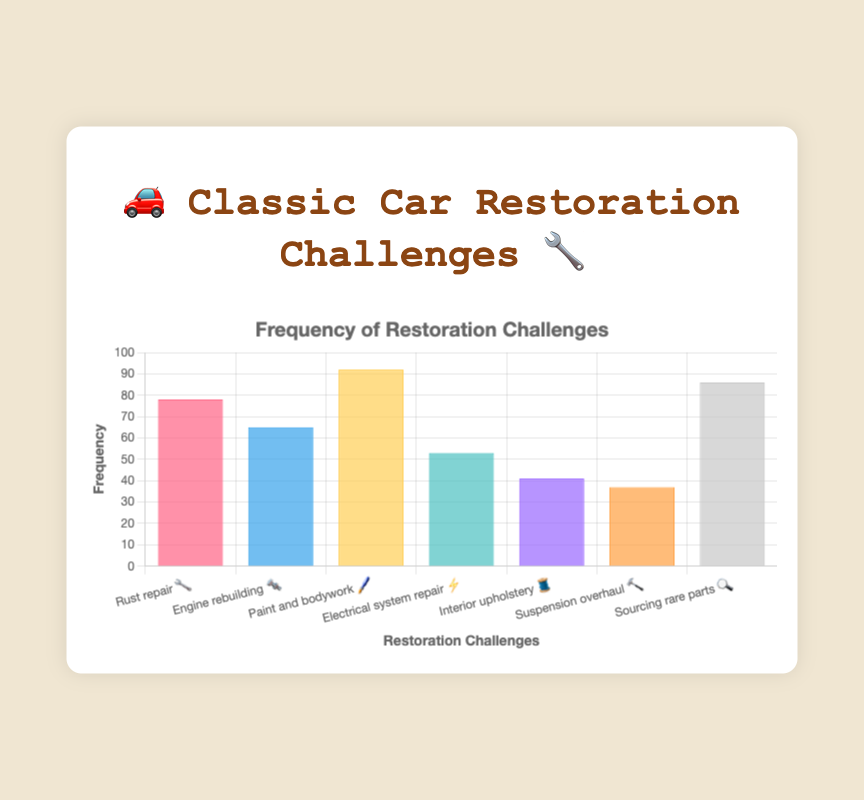what's the highest frequency challenge? The tallest bar in the chart represents the "Paint and bodywork 🖌️" with a frequency of 92.
Answer: Paint and bodywork 🖌️ what's the lowest frequency challenge? The shortest bar in the chart corresponds to the "Suspension overhaul 🔨" with a frequency of 37.
Answer: Suspension overhaul 🔨 which challenge has a frequency of 86? The bar representing "Sourcing rare parts 🔍" has a frequency of 86, as shown by its height.
Answer: Sourcing rare parts 🔍 what is the combined frequency of "Rust repair 🔧" and "Engine rebuilding 🔩"? The sum of the frequencies of "Rust repair 🔧" (78) and "Engine rebuilding 🔩" (65) is 78 + 65 = 143.
Answer: 143 how many challenges have a frequency greater than 50? The challenges with frequencies higher than 50 are "Rust repair 🔧" (78), "Engine rebuilding 🔩" (65), "Paint and bodywork 🖌️" (92), "Electrical system repair ⚡" (53), and "Sourcing rare parts 🔍" (86), totaling 5 challenges.
Answer: 5 which challenge has the second-highest frequency? The second tallest bar represents "Sourcing rare parts 🔍", which has a frequency of 86, placing it second after "Paint and bodywork 🖌️".
Answer: Sourcing rare parts 🔍 is "Interior upholstery 🧵" more or less frequent than "Electrical system repair ⚡"? The "Interior upholstery 🧵" bar has a frequency of 41, while the "Electrical system repair ⚡" bar has a frequency of 53, so "Interior upholstery 🧵" is less frequent than "Electrical system repair ⚡".
Answer: Less frequent what's the total frequency for all challenges combined? Adding the frequencies of all challenges: 78 (Rust repair) + 65 (Engine rebuilding) + 92 (Paint and bodywork) + 53 (Electrical system repair) + 41 (Interior upholstery) + 37 (Suspension overhaul) + 86 (Sourcing rare parts) gives a total of 452.
Answer: 452 which challenges have frequencies between 50 and 80 inclusive? The challenges with frequencies in this range are "Rust repair 🔧" (78), "Engine rebuilding 🔩" (65), and "Electrical system repair ⚡" (53).
Answer: Rust repair 🔧, Engine rebuilding 🔩, Electrical system repair ⚡ what's the average frequency of all the challenges? To find the average, sum all frequencies (452) and divide by the number of challenges (7). So, 452/7 = 64.57.
Answer: 64.57 